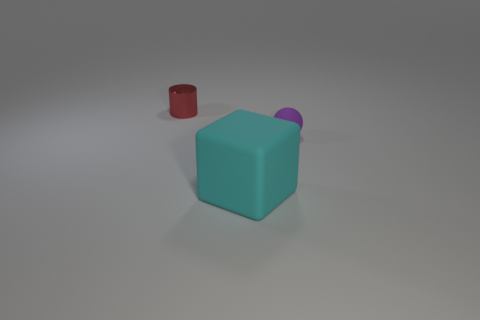Add 3 large cyan metal blocks. How many objects exist? 6 Subtract 0 blue cylinders. How many objects are left? 3 Subtract all balls. How many objects are left? 2 Subtract 1 cylinders. How many cylinders are left? 0 Subtract all green balls. Subtract all brown cylinders. How many balls are left? 1 Subtract all brown balls. How many green cylinders are left? 0 Subtract all small green rubber balls. Subtract all tiny matte things. How many objects are left? 2 Add 2 big cyan things. How many big cyan things are left? 3 Add 3 tiny red rubber blocks. How many tiny red rubber blocks exist? 3 